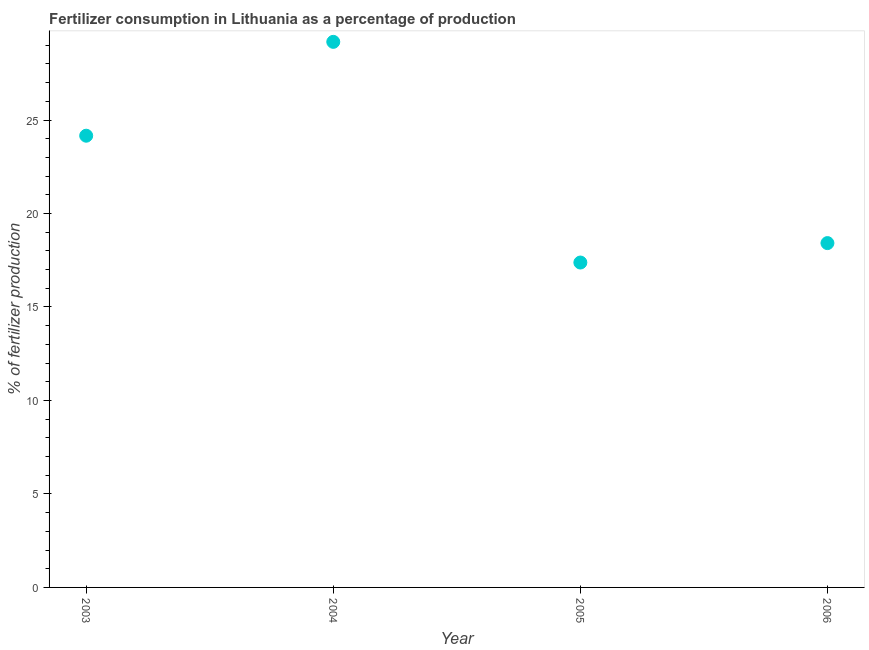What is the amount of fertilizer consumption in 2004?
Your response must be concise. 29.18. Across all years, what is the maximum amount of fertilizer consumption?
Your response must be concise. 29.18. Across all years, what is the minimum amount of fertilizer consumption?
Your answer should be compact. 17.38. What is the sum of the amount of fertilizer consumption?
Offer a terse response. 89.14. What is the difference between the amount of fertilizer consumption in 2003 and 2005?
Keep it short and to the point. 6.78. What is the average amount of fertilizer consumption per year?
Offer a very short reply. 22.28. What is the median amount of fertilizer consumption?
Offer a very short reply. 21.29. In how many years, is the amount of fertilizer consumption greater than 6 %?
Offer a very short reply. 4. Do a majority of the years between 2003 and 2004 (inclusive) have amount of fertilizer consumption greater than 1 %?
Your response must be concise. Yes. What is the ratio of the amount of fertilizer consumption in 2003 to that in 2006?
Your answer should be very brief. 1.31. Is the difference between the amount of fertilizer consumption in 2003 and 2004 greater than the difference between any two years?
Give a very brief answer. No. What is the difference between the highest and the second highest amount of fertilizer consumption?
Your answer should be very brief. 5.02. Is the sum of the amount of fertilizer consumption in 2003 and 2006 greater than the maximum amount of fertilizer consumption across all years?
Keep it short and to the point. Yes. What is the difference between the highest and the lowest amount of fertilizer consumption?
Make the answer very short. 11.8. Does the amount of fertilizer consumption monotonically increase over the years?
Ensure brevity in your answer.  No. How many years are there in the graph?
Make the answer very short. 4. What is the difference between two consecutive major ticks on the Y-axis?
Offer a terse response. 5. Are the values on the major ticks of Y-axis written in scientific E-notation?
Offer a very short reply. No. Does the graph contain any zero values?
Ensure brevity in your answer.  No. What is the title of the graph?
Your answer should be compact. Fertilizer consumption in Lithuania as a percentage of production. What is the label or title of the X-axis?
Your answer should be very brief. Year. What is the label or title of the Y-axis?
Your response must be concise. % of fertilizer production. What is the % of fertilizer production in 2003?
Your response must be concise. 24.16. What is the % of fertilizer production in 2004?
Provide a succinct answer. 29.18. What is the % of fertilizer production in 2005?
Keep it short and to the point. 17.38. What is the % of fertilizer production in 2006?
Make the answer very short. 18.42. What is the difference between the % of fertilizer production in 2003 and 2004?
Provide a succinct answer. -5.02. What is the difference between the % of fertilizer production in 2003 and 2005?
Your response must be concise. 6.78. What is the difference between the % of fertilizer production in 2003 and 2006?
Keep it short and to the point. 5.74. What is the difference between the % of fertilizer production in 2004 and 2005?
Offer a terse response. 11.8. What is the difference between the % of fertilizer production in 2004 and 2006?
Your answer should be compact. 10.76. What is the difference between the % of fertilizer production in 2005 and 2006?
Offer a very short reply. -1.04. What is the ratio of the % of fertilizer production in 2003 to that in 2004?
Your response must be concise. 0.83. What is the ratio of the % of fertilizer production in 2003 to that in 2005?
Ensure brevity in your answer.  1.39. What is the ratio of the % of fertilizer production in 2003 to that in 2006?
Keep it short and to the point. 1.31. What is the ratio of the % of fertilizer production in 2004 to that in 2005?
Keep it short and to the point. 1.68. What is the ratio of the % of fertilizer production in 2004 to that in 2006?
Make the answer very short. 1.58. What is the ratio of the % of fertilizer production in 2005 to that in 2006?
Your response must be concise. 0.94. 